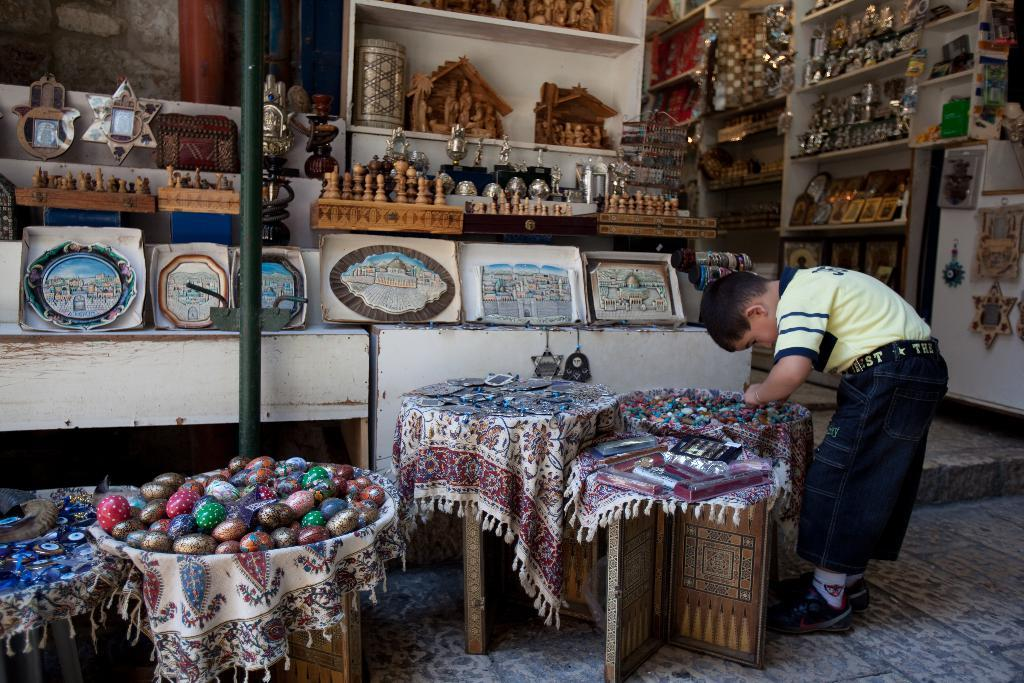What is the main subject of the image? There is a person standing in the image. What can be seen in the background of the image? There are frames and wooden objects in racks in the background of the image. What type of objects are visible in the image? There are colorful objects visible in the image. What is the reaction of the tin can in the image? There is no tin can present in the image, so it is not possible to determine its reaction. 